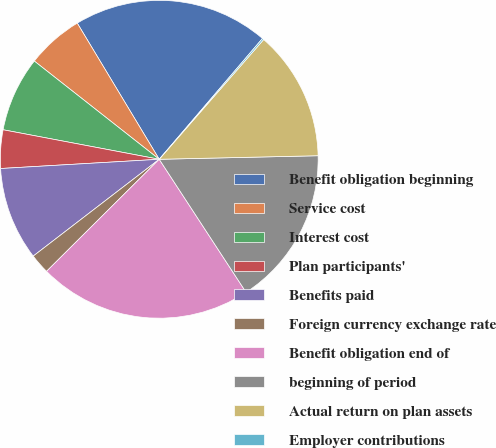Convert chart. <chart><loc_0><loc_0><loc_500><loc_500><pie_chart><fcel>Benefit obligation beginning<fcel>Service cost<fcel>Interest cost<fcel>Plan participants'<fcel>Benefits paid<fcel>Foreign currency exchange rate<fcel>Benefit obligation end of<fcel>beginning of period<fcel>Actual return on plan assets<fcel>Employer contributions<nl><fcel>19.88%<fcel>5.77%<fcel>7.63%<fcel>3.9%<fcel>9.5%<fcel>2.03%<fcel>21.75%<fcel>16.15%<fcel>13.23%<fcel>0.16%<nl></chart> 